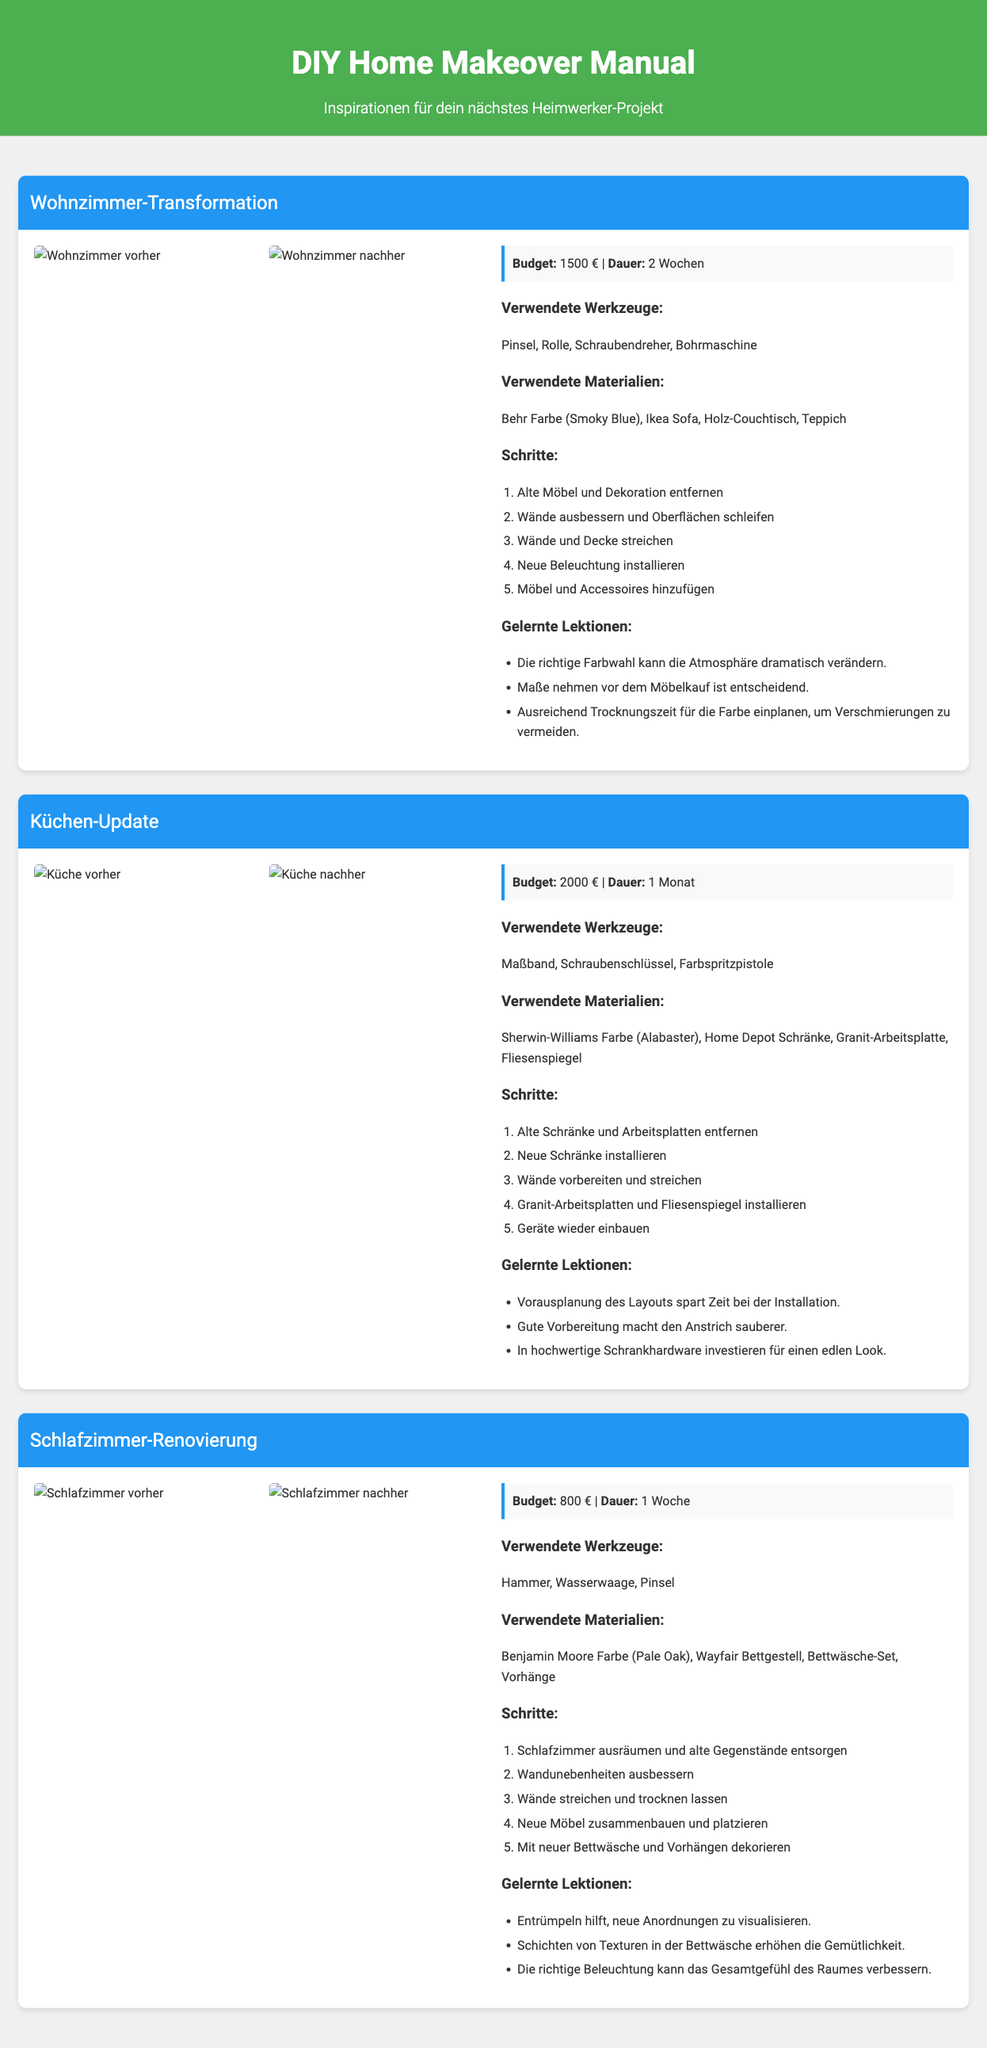What is the budget for the Wohnzimmer-Transformation? The budget is clearly stated in the project details section for the Wohnzimmer-Transformation.
Answer: 1500 € How long did the Küchen-Update take? The duration is mentioned in the project details for the Küchen-Update.
Answer: 1 Monat Which color was used for the Schlafzimmer-Renovierung? The used color is specified under the materials used in the Schlafzimmer-Renovierung section.
Answer: Pale Oak What tools were used for the Wohnzimmer-Transformation? The tools used are listed in the project details of the Wohnzimmer-Transformation.
Answer: Pinsel, Rolle, Schraubendreher, Bohrmaschine What lesson was learned from the Küchen-Update? The lessons learned are enumerated in the project details of the Küchen-Update.
Answer: Vorausplanung des Layouts spart Zeit bei der Installation How many steps are listed for the Schlafzimmer-Renovierung? The number of steps can be counted in the steps section of the Schlafzimmer-Renovierung.
Answer: 5 What is the main theme of the document? The theme can be inferred from the title and subtitle of the manual.
Answer: DIY Home Makeover What was the main focus of the project titled "Küchen-Update"? The main focus is described in the project header and contents regarding what was updated.
Answer: Küchen What is the color of the walls in the Wohnzimmer-Transformation after the makeover? The color is specified under the materials used in the Wohnzimmer-Transformation.
Answer: Smoky Blue 